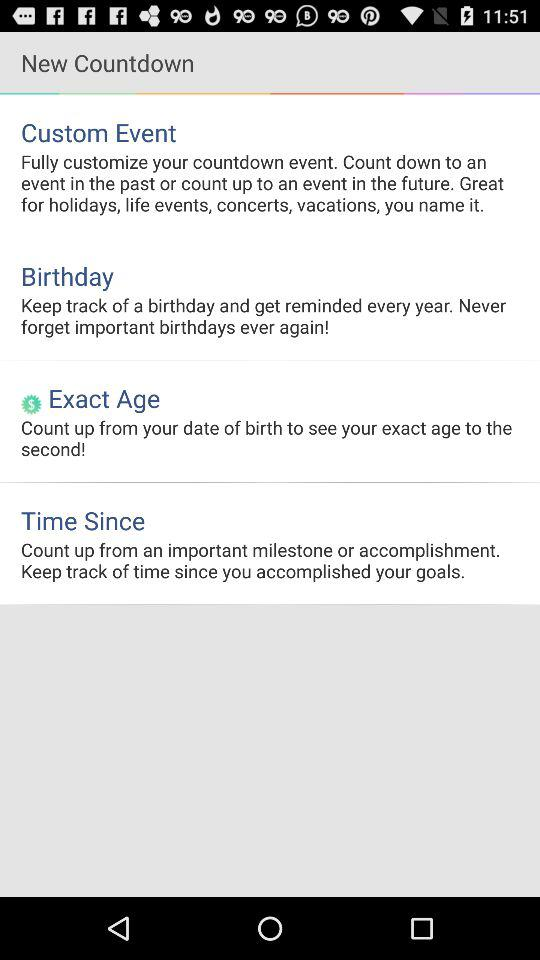How many countdown types are available?
Answer the question using a single word or phrase. 4 